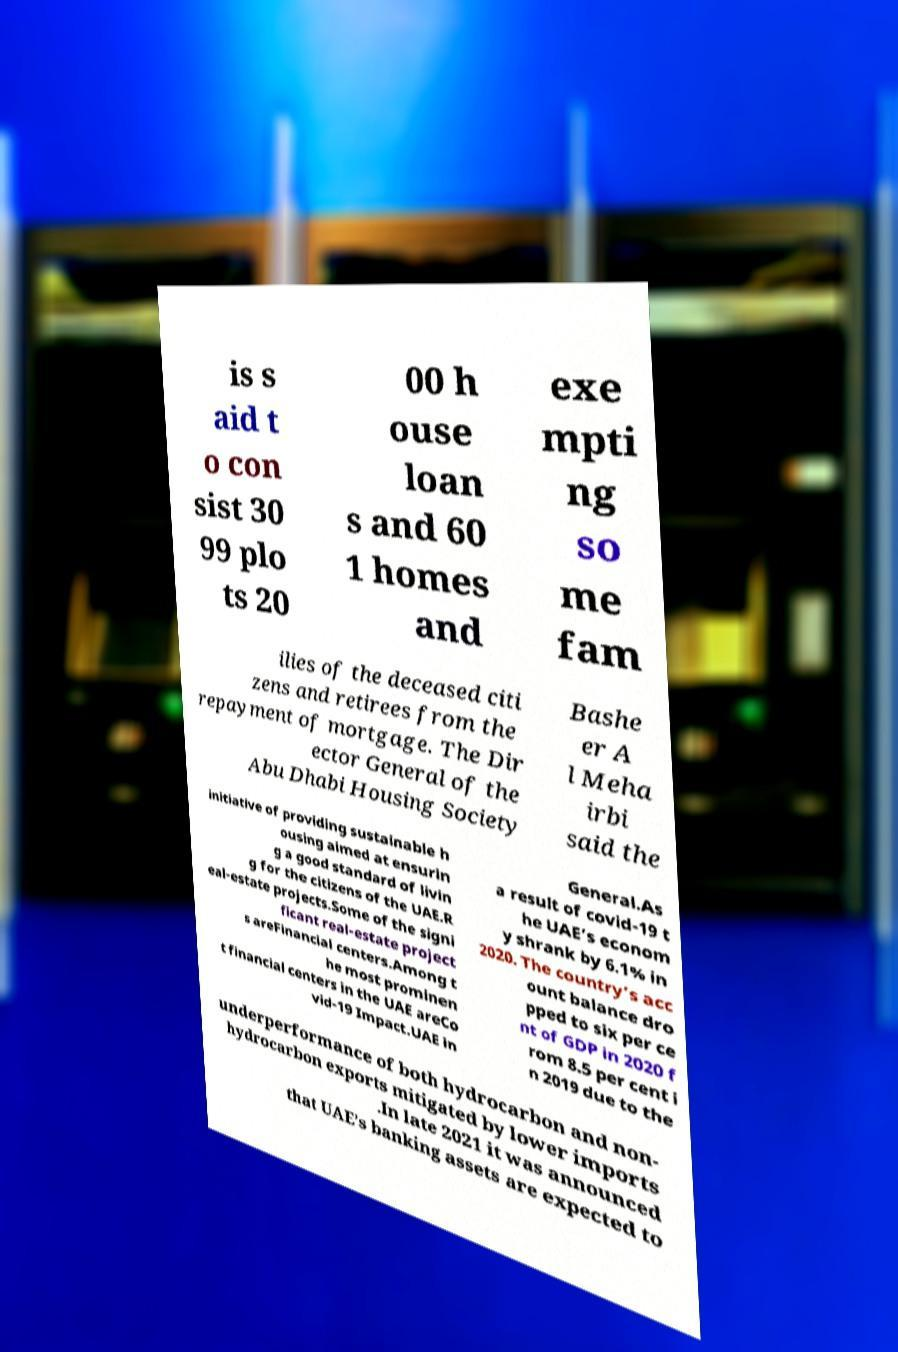There's text embedded in this image that I need extracted. Can you transcribe it verbatim? is s aid t o con sist 30 99 plo ts 20 00 h ouse loan s and 60 1 homes and exe mpti ng so me fam ilies of the deceased citi zens and retirees from the repayment of mortgage. The Dir ector General of the Abu Dhabi Housing Society Bashe er A l Meha irbi said the initiative of providing sustainable h ousing aimed at ensurin g a good standard of livin g for the citizens of the UAE.R eal-estate projects.Some of the signi ficant real-estate project s areFinancial centers.Among t he most prominen t financial centers in the UAE areCo vid-19 Impact.UAE in General.As a result of covid-19 t he UAE’s econom y shrank by 6.1% in 2020. The country’s acc ount balance dro pped to six per ce nt of GDP in 2020 f rom 8.5 per cent i n 2019 due to the underperformance of both hydrocarbon and non- hydrocarbon exports mitigated by lower imports .In late 2021 it was announced that UAE’s banking assets are expected to 